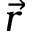<formula> <loc_0><loc_0><loc_500><loc_500>\vec { r }</formula> 